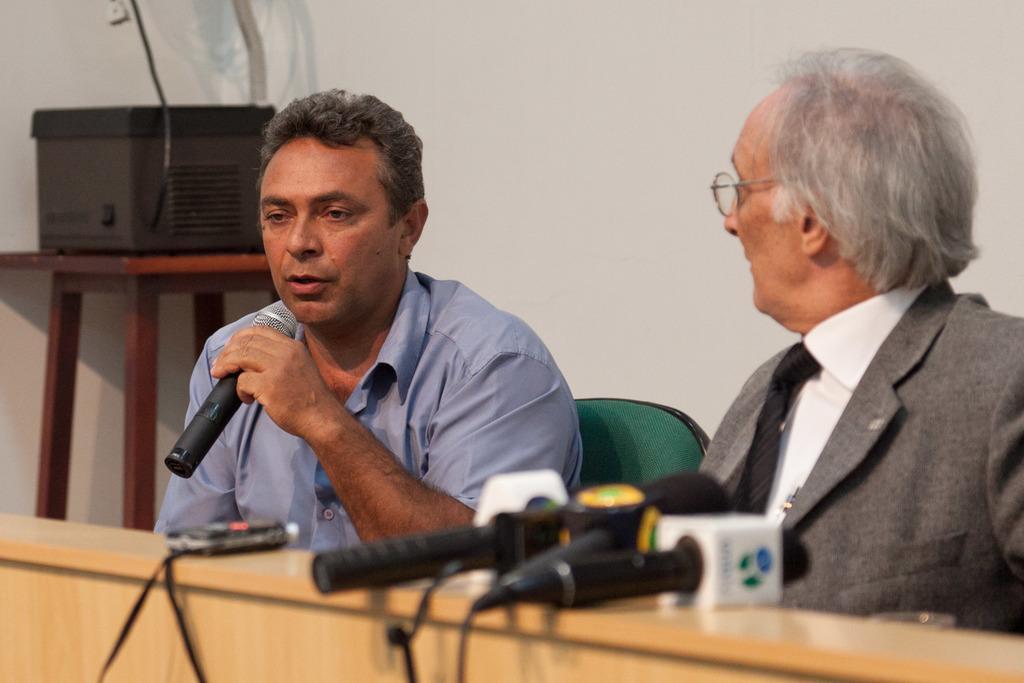Can you describe this image briefly? This picture is of inside the room. On the right there is a man wearing suit and sitting on the chair. In the center there is a man wearing blue color shirt, holding a microphone, talking and sitting on the chair. There is a table on the top of which microphones are placed. On the left there is a table on the top of which a machine is placed. In the background there is a wall. 